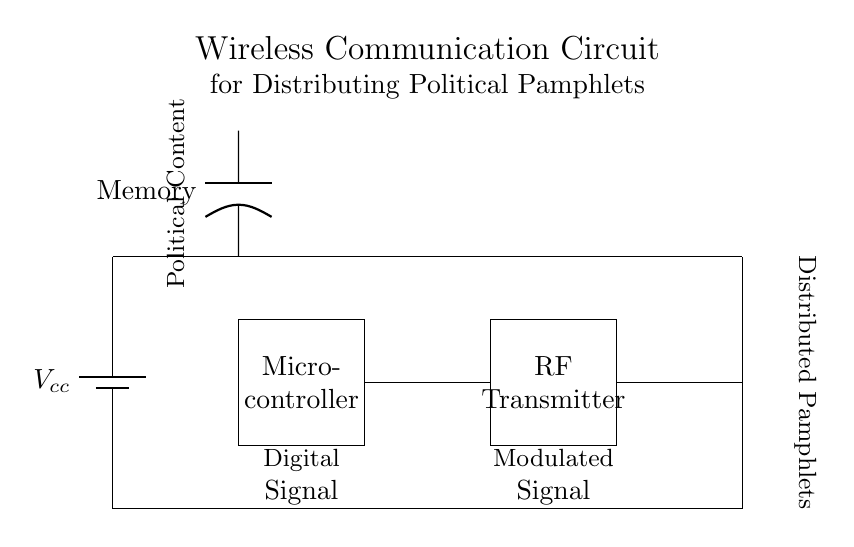What is the main power source in the circuit? The main power source is a battery, identified by the component labeled as "Vcc". This is the component providing electrical energy to the circuit.
Answer: battery What does the microcontroller do in this circuit? The microcontroller is a component that processes the digital signal. It takes input data and controls the RF transmitter to distribute the political pamphlets.
Answer: processes signal What type of signal does the RF transmitter output? The RF transmitter outputs a modulated signal, which is designed to be transmitted over radio frequencies for distributing the pamphlets.
Answer: modulated signal What is the role of the antenna in this circuit? The antenna serves to radiate the modulated signal into the air, allowing the political pamphlet content to be transmitted wirelessly over a distance.
Answer: radiates signal How is the memory connected to the circuit? The memory is connected to the microcontroller via a direct connection, which allows the microcontroller to access stored political content for processing.
Answer: direct connection What does the circuit aim to distribute? The circuit is designed to distribute political pamphlets, which are the contents that the RF transmitter broadcasts in a wireless manner.
Answer: political pamphlets 